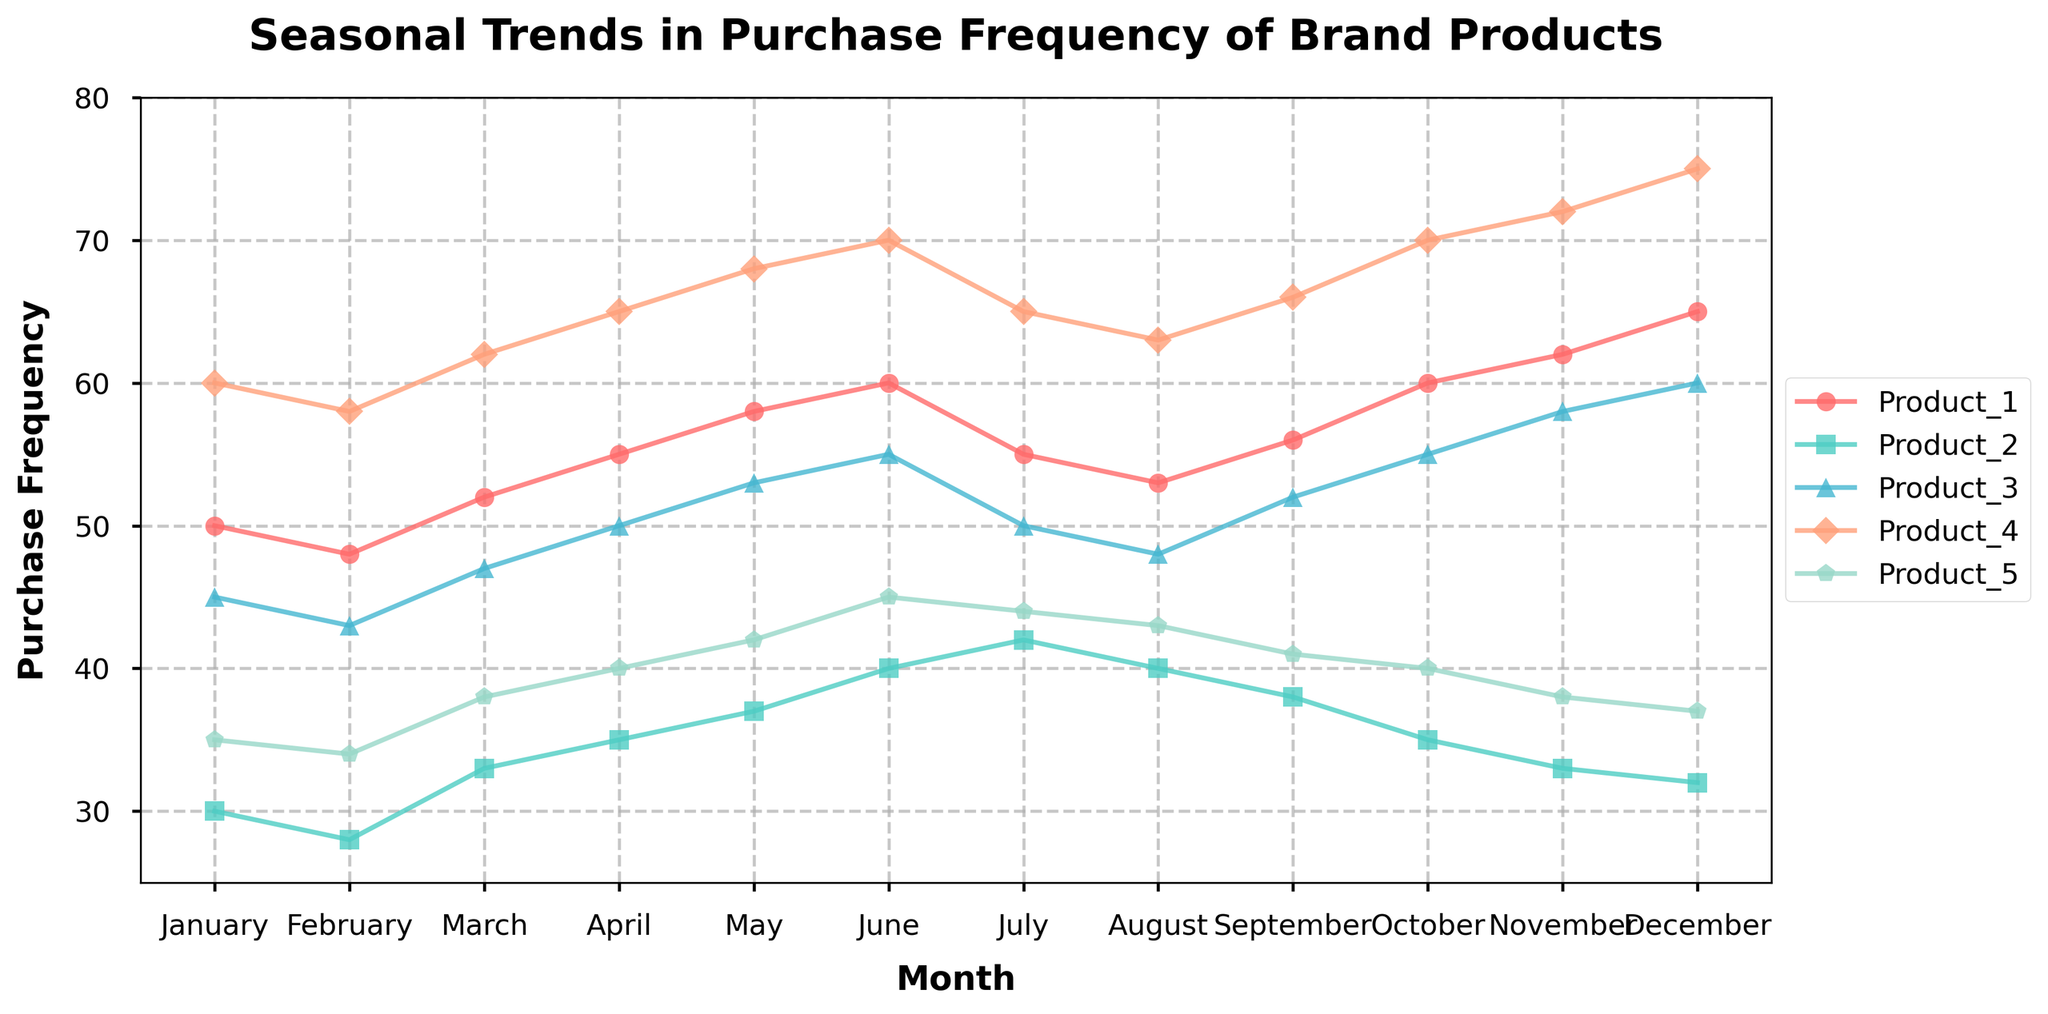What is the title of the figure? The title is located at the top of the figure. It states "Seasonal Trends in Purchase Frequency of Brand Products."
Answer: Seasonal Trends in Purchase Frequency of Brand Products Which months have the highest purchase frequency for Product_4? By observing the peaks in the line for Product_4, the highest purchase frequencies appear in October, November, and December.
Answer: October, November, December What is the purchase frequency difference for Product_5 between March and December? In March, Product_5 has a purchase frequency of 38, and in December, it has a frequency of 37. The difference is calculated as 38 - 37.
Answer: 1 Which product has the least purchase frequency in June? By looking at the values for each product in June, Product_2 has the least purchase frequency, which is 40.
Answer: Product_2 During which month does Product_1 have the highest purchase frequency, and what is that frequency? The highest purchase frequency for Product_1 is observed in December, where the frequency is 65.
Answer: December, 65 For which product(s) does the purchase frequency decrease in August compared to July? By comparing the values for each product in July and August, Product_1 and Product_3 show a decrease (Product_1: 55 to 53, Product_3: 50 to 48).
Answer: Product_1, Product_3 How does the purchase frequency of Product_3 change from April to May? The purchase frequency for Product_3 in April is 50 and in May is 53. This means there is an increase of 53 - 50.
Answer: Increase by 3 What is the average purchase frequency of Product_1 over the entire year? The purchase frequencies for Product_1 are summed up and divided by 12 (number of months): (50 + 48 + 52 + 55 + 58 + 60 + 55 + 53 + 56 + 60 + 62 + 65) / 12 = 56.
Answer: 56 Which product experiences the smallest overall fluctuation in purchase frequency over the year? By examining the range of values for each product, Product_2 fluctuates between 28 and 42, resulting in a range of 14, which is the smallest among all products.
Answer: Product_2 